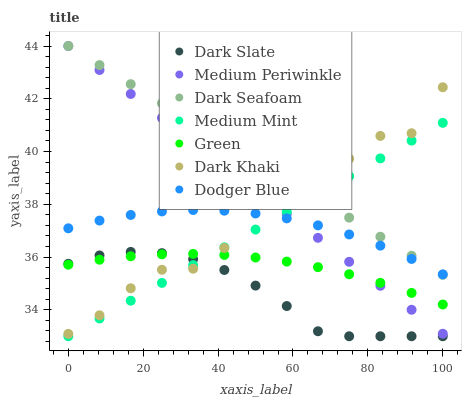Does Dark Slate have the minimum area under the curve?
Answer yes or no. Yes. Does Dark Seafoam have the maximum area under the curve?
Answer yes or no. Yes. Does Medium Periwinkle have the minimum area under the curve?
Answer yes or no. No. Does Medium Periwinkle have the maximum area under the curve?
Answer yes or no. No. Is Medium Periwinkle the smoothest?
Answer yes or no. Yes. Is Dark Khaki the roughest?
Answer yes or no. Yes. Is Dark Khaki the smoothest?
Answer yes or no. No. Is Medium Periwinkle the roughest?
Answer yes or no. No. Does Medium Mint have the lowest value?
Answer yes or no. Yes. Does Medium Periwinkle have the lowest value?
Answer yes or no. No. Does Dark Seafoam have the highest value?
Answer yes or no. Yes. Does Dark Khaki have the highest value?
Answer yes or no. No. Is Dark Slate less than Dodger Blue?
Answer yes or no. Yes. Is Dodger Blue greater than Dark Slate?
Answer yes or no. Yes. Does Medium Mint intersect Medium Periwinkle?
Answer yes or no. Yes. Is Medium Mint less than Medium Periwinkle?
Answer yes or no. No. Is Medium Mint greater than Medium Periwinkle?
Answer yes or no. No. Does Dark Slate intersect Dodger Blue?
Answer yes or no. No. 